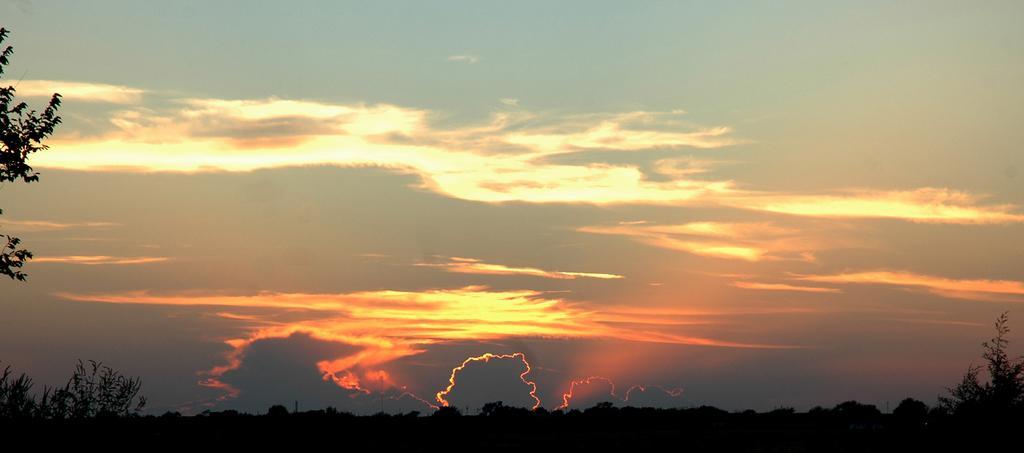Describe this image in one or two sentences. This picture is clicked outside the city. In the foreground we can see the plants and trees. On the left corner there is a tree. In the background there is a sky with the clouds. 